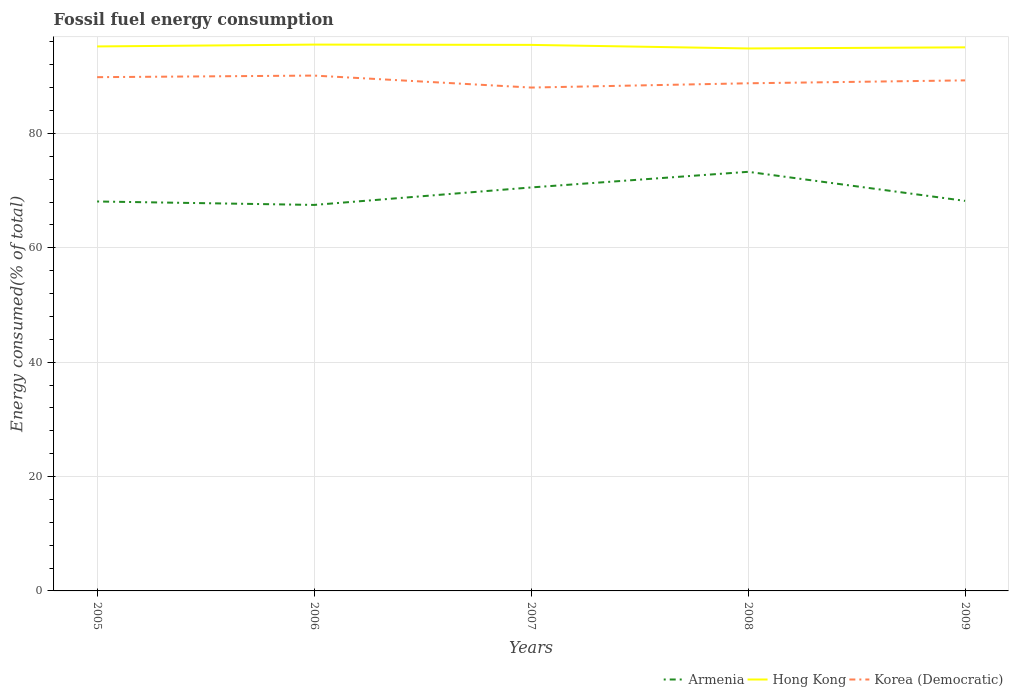Across all years, what is the maximum percentage of energy consumed in Armenia?
Provide a short and direct response. 67.5. In which year was the percentage of energy consumed in Armenia maximum?
Keep it short and to the point. 2006. What is the total percentage of energy consumed in Armenia in the graph?
Your response must be concise. -0.71. What is the difference between the highest and the second highest percentage of energy consumed in Hong Kong?
Your answer should be very brief. 0.67. How many years are there in the graph?
Keep it short and to the point. 5. What is the difference between two consecutive major ticks on the Y-axis?
Offer a very short reply. 20. Does the graph contain grids?
Your response must be concise. Yes. How many legend labels are there?
Ensure brevity in your answer.  3. What is the title of the graph?
Offer a very short reply. Fossil fuel energy consumption. Does "Peru" appear as one of the legend labels in the graph?
Keep it short and to the point. No. What is the label or title of the X-axis?
Your response must be concise. Years. What is the label or title of the Y-axis?
Offer a terse response. Energy consumed(% of total). What is the Energy consumed(% of total) in Armenia in 2005?
Offer a terse response. 68.1. What is the Energy consumed(% of total) in Hong Kong in 2005?
Your answer should be compact. 95.21. What is the Energy consumed(% of total) in Korea (Democratic) in 2005?
Keep it short and to the point. 89.84. What is the Energy consumed(% of total) in Armenia in 2006?
Offer a terse response. 67.5. What is the Energy consumed(% of total) of Hong Kong in 2006?
Your answer should be compact. 95.53. What is the Energy consumed(% of total) in Korea (Democratic) in 2006?
Give a very brief answer. 90.11. What is the Energy consumed(% of total) of Armenia in 2007?
Keep it short and to the point. 70.55. What is the Energy consumed(% of total) in Hong Kong in 2007?
Your answer should be compact. 95.48. What is the Energy consumed(% of total) in Korea (Democratic) in 2007?
Ensure brevity in your answer.  88.02. What is the Energy consumed(% of total) in Armenia in 2008?
Your answer should be compact. 73.29. What is the Energy consumed(% of total) in Hong Kong in 2008?
Ensure brevity in your answer.  94.86. What is the Energy consumed(% of total) in Korea (Democratic) in 2008?
Your answer should be compact. 88.77. What is the Energy consumed(% of total) of Armenia in 2009?
Offer a very short reply. 68.2. What is the Energy consumed(% of total) of Hong Kong in 2009?
Your answer should be very brief. 95.05. What is the Energy consumed(% of total) in Korea (Democratic) in 2009?
Provide a short and direct response. 89.28. Across all years, what is the maximum Energy consumed(% of total) in Armenia?
Provide a short and direct response. 73.29. Across all years, what is the maximum Energy consumed(% of total) in Hong Kong?
Provide a short and direct response. 95.53. Across all years, what is the maximum Energy consumed(% of total) in Korea (Democratic)?
Provide a succinct answer. 90.11. Across all years, what is the minimum Energy consumed(% of total) in Armenia?
Provide a short and direct response. 67.5. Across all years, what is the minimum Energy consumed(% of total) in Hong Kong?
Your answer should be very brief. 94.86. Across all years, what is the minimum Energy consumed(% of total) in Korea (Democratic)?
Your response must be concise. 88.02. What is the total Energy consumed(% of total) in Armenia in the graph?
Provide a short and direct response. 347.64. What is the total Energy consumed(% of total) of Hong Kong in the graph?
Provide a succinct answer. 476.13. What is the total Energy consumed(% of total) in Korea (Democratic) in the graph?
Provide a succinct answer. 446.01. What is the difference between the Energy consumed(% of total) of Armenia in 2005 and that in 2006?
Your answer should be very brief. 0.6. What is the difference between the Energy consumed(% of total) in Hong Kong in 2005 and that in 2006?
Your answer should be very brief. -0.32. What is the difference between the Energy consumed(% of total) in Korea (Democratic) in 2005 and that in 2006?
Ensure brevity in your answer.  -0.28. What is the difference between the Energy consumed(% of total) of Armenia in 2005 and that in 2007?
Make the answer very short. -2.45. What is the difference between the Energy consumed(% of total) of Hong Kong in 2005 and that in 2007?
Offer a very short reply. -0.27. What is the difference between the Energy consumed(% of total) of Korea (Democratic) in 2005 and that in 2007?
Your answer should be very brief. 1.82. What is the difference between the Energy consumed(% of total) of Armenia in 2005 and that in 2008?
Give a very brief answer. -5.19. What is the difference between the Energy consumed(% of total) of Hong Kong in 2005 and that in 2008?
Keep it short and to the point. 0.35. What is the difference between the Energy consumed(% of total) in Korea (Democratic) in 2005 and that in 2008?
Provide a succinct answer. 1.07. What is the difference between the Energy consumed(% of total) of Armenia in 2005 and that in 2009?
Offer a very short reply. -0.11. What is the difference between the Energy consumed(% of total) of Hong Kong in 2005 and that in 2009?
Provide a short and direct response. 0.16. What is the difference between the Energy consumed(% of total) of Korea (Democratic) in 2005 and that in 2009?
Your answer should be compact. 0.56. What is the difference between the Energy consumed(% of total) in Armenia in 2006 and that in 2007?
Provide a succinct answer. -3.06. What is the difference between the Energy consumed(% of total) in Hong Kong in 2006 and that in 2007?
Offer a very short reply. 0.05. What is the difference between the Energy consumed(% of total) of Korea (Democratic) in 2006 and that in 2007?
Offer a very short reply. 2.09. What is the difference between the Energy consumed(% of total) in Armenia in 2006 and that in 2008?
Offer a terse response. -5.79. What is the difference between the Energy consumed(% of total) in Hong Kong in 2006 and that in 2008?
Offer a very short reply. 0.67. What is the difference between the Energy consumed(% of total) of Korea (Democratic) in 2006 and that in 2008?
Keep it short and to the point. 1.35. What is the difference between the Energy consumed(% of total) of Armenia in 2006 and that in 2009?
Give a very brief answer. -0.71. What is the difference between the Energy consumed(% of total) in Hong Kong in 2006 and that in 2009?
Ensure brevity in your answer.  0.48. What is the difference between the Energy consumed(% of total) in Korea (Democratic) in 2006 and that in 2009?
Provide a succinct answer. 0.84. What is the difference between the Energy consumed(% of total) in Armenia in 2007 and that in 2008?
Your answer should be compact. -2.73. What is the difference between the Energy consumed(% of total) of Hong Kong in 2007 and that in 2008?
Offer a very short reply. 0.62. What is the difference between the Energy consumed(% of total) in Korea (Democratic) in 2007 and that in 2008?
Make the answer very short. -0.75. What is the difference between the Energy consumed(% of total) in Armenia in 2007 and that in 2009?
Provide a short and direct response. 2.35. What is the difference between the Energy consumed(% of total) of Hong Kong in 2007 and that in 2009?
Keep it short and to the point. 0.43. What is the difference between the Energy consumed(% of total) in Korea (Democratic) in 2007 and that in 2009?
Make the answer very short. -1.26. What is the difference between the Energy consumed(% of total) in Armenia in 2008 and that in 2009?
Provide a short and direct response. 5.08. What is the difference between the Energy consumed(% of total) in Hong Kong in 2008 and that in 2009?
Make the answer very short. -0.19. What is the difference between the Energy consumed(% of total) in Korea (Democratic) in 2008 and that in 2009?
Make the answer very short. -0.51. What is the difference between the Energy consumed(% of total) of Armenia in 2005 and the Energy consumed(% of total) of Hong Kong in 2006?
Provide a short and direct response. -27.43. What is the difference between the Energy consumed(% of total) in Armenia in 2005 and the Energy consumed(% of total) in Korea (Democratic) in 2006?
Your answer should be compact. -22.01. What is the difference between the Energy consumed(% of total) of Hong Kong in 2005 and the Energy consumed(% of total) of Korea (Democratic) in 2006?
Provide a succinct answer. 5.1. What is the difference between the Energy consumed(% of total) in Armenia in 2005 and the Energy consumed(% of total) in Hong Kong in 2007?
Provide a succinct answer. -27.38. What is the difference between the Energy consumed(% of total) in Armenia in 2005 and the Energy consumed(% of total) in Korea (Democratic) in 2007?
Ensure brevity in your answer.  -19.92. What is the difference between the Energy consumed(% of total) of Hong Kong in 2005 and the Energy consumed(% of total) of Korea (Democratic) in 2007?
Your response must be concise. 7.19. What is the difference between the Energy consumed(% of total) of Armenia in 2005 and the Energy consumed(% of total) of Hong Kong in 2008?
Ensure brevity in your answer.  -26.76. What is the difference between the Energy consumed(% of total) of Armenia in 2005 and the Energy consumed(% of total) of Korea (Democratic) in 2008?
Your answer should be very brief. -20.67. What is the difference between the Energy consumed(% of total) in Hong Kong in 2005 and the Energy consumed(% of total) in Korea (Democratic) in 2008?
Keep it short and to the point. 6.44. What is the difference between the Energy consumed(% of total) of Armenia in 2005 and the Energy consumed(% of total) of Hong Kong in 2009?
Your answer should be compact. -26.95. What is the difference between the Energy consumed(% of total) in Armenia in 2005 and the Energy consumed(% of total) in Korea (Democratic) in 2009?
Provide a succinct answer. -21.18. What is the difference between the Energy consumed(% of total) of Hong Kong in 2005 and the Energy consumed(% of total) of Korea (Democratic) in 2009?
Your response must be concise. 5.93. What is the difference between the Energy consumed(% of total) in Armenia in 2006 and the Energy consumed(% of total) in Hong Kong in 2007?
Your answer should be compact. -27.98. What is the difference between the Energy consumed(% of total) of Armenia in 2006 and the Energy consumed(% of total) of Korea (Democratic) in 2007?
Your response must be concise. -20.52. What is the difference between the Energy consumed(% of total) in Hong Kong in 2006 and the Energy consumed(% of total) in Korea (Democratic) in 2007?
Provide a succinct answer. 7.51. What is the difference between the Energy consumed(% of total) in Armenia in 2006 and the Energy consumed(% of total) in Hong Kong in 2008?
Ensure brevity in your answer.  -27.36. What is the difference between the Energy consumed(% of total) in Armenia in 2006 and the Energy consumed(% of total) in Korea (Democratic) in 2008?
Your answer should be very brief. -21.27. What is the difference between the Energy consumed(% of total) of Hong Kong in 2006 and the Energy consumed(% of total) of Korea (Democratic) in 2008?
Give a very brief answer. 6.77. What is the difference between the Energy consumed(% of total) of Armenia in 2006 and the Energy consumed(% of total) of Hong Kong in 2009?
Your answer should be compact. -27.55. What is the difference between the Energy consumed(% of total) of Armenia in 2006 and the Energy consumed(% of total) of Korea (Democratic) in 2009?
Make the answer very short. -21.78. What is the difference between the Energy consumed(% of total) in Hong Kong in 2006 and the Energy consumed(% of total) in Korea (Democratic) in 2009?
Keep it short and to the point. 6.26. What is the difference between the Energy consumed(% of total) of Armenia in 2007 and the Energy consumed(% of total) of Hong Kong in 2008?
Your answer should be very brief. -24.3. What is the difference between the Energy consumed(% of total) of Armenia in 2007 and the Energy consumed(% of total) of Korea (Democratic) in 2008?
Provide a succinct answer. -18.21. What is the difference between the Energy consumed(% of total) of Hong Kong in 2007 and the Energy consumed(% of total) of Korea (Democratic) in 2008?
Your answer should be very brief. 6.71. What is the difference between the Energy consumed(% of total) in Armenia in 2007 and the Energy consumed(% of total) in Hong Kong in 2009?
Keep it short and to the point. -24.5. What is the difference between the Energy consumed(% of total) of Armenia in 2007 and the Energy consumed(% of total) of Korea (Democratic) in 2009?
Keep it short and to the point. -18.72. What is the difference between the Energy consumed(% of total) in Hong Kong in 2007 and the Energy consumed(% of total) in Korea (Democratic) in 2009?
Give a very brief answer. 6.2. What is the difference between the Energy consumed(% of total) of Armenia in 2008 and the Energy consumed(% of total) of Hong Kong in 2009?
Make the answer very short. -21.76. What is the difference between the Energy consumed(% of total) of Armenia in 2008 and the Energy consumed(% of total) of Korea (Democratic) in 2009?
Your answer should be compact. -15.99. What is the difference between the Energy consumed(% of total) in Hong Kong in 2008 and the Energy consumed(% of total) in Korea (Democratic) in 2009?
Offer a terse response. 5.58. What is the average Energy consumed(% of total) of Armenia per year?
Make the answer very short. 69.53. What is the average Energy consumed(% of total) of Hong Kong per year?
Your answer should be compact. 95.23. What is the average Energy consumed(% of total) in Korea (Democratic) per year?
Provide a succinct answer. 89.2. In the year 2005, what is the difference between the Energy consumed(% of total) of Armenia and Energy consumed(% of total) of Hong Kong?
Your response must be concise. -27.11. In the year 2005, what is the difference between the Energy consumed(% of total) of Armenia and Energy consumed(% of total) of Korea (Democratic)?
Provide a short and direct response. -21.74. In the year 2005, what is the difference between the Energy consumed(% of total) in Hong Kong and Energy consumed(% of total) in Korea (Democratic)?
Provide a succinct answer. 5.37. In the year 2006, what is the difference between the Energy consumed(% of total) in Armenia and Energy consumed(% of total) in Hong Kong?
Provide a short and direct response. -28.04. In the year 2006, what is the difference between the Energy consumed(% of total) of Armenia and Energy consumed(% of total) of Korea (Democratic)?
Offer a terse response. -22.62. In the year 2006, what is the difference between the Energy consumed(% of total) of Hong Kong and Energy consumed(% of total) of Korea (Democratic)?
Keep it short and to the point. 5.42. In the year 2007, what is the difference between the Energy consumed(% of total) of Armenia and Energy consumed(% of total) of Hong Kong?
Provide a short and direct response. -24.93. In the year 2007, what is the difference between the Energy consumed(% of total) of Armenia and Energy consumed(% of total) of Korea (Democratic)?
Your answer should be very brief. -17.47. In the year 2007, what is the difference between the Energy consumed(% of total) of Hong Kong and Energy consumed(% of total) of Korea (Democratic)?
Provide a succinct answer. 7.46. In the year 2008, what is the difference between the Energy consumed(% of total) in Armenia and Energy consumed(% of total) in Hong Kong?
Keep it short and to the point. -21.57. In the year 2008, what is the difference between the Energy consumed(% of total) in Armenia and Energy consumed(% of total) in Korea (Democratic)?
Your answer should be compact. -15.48. In the year 2008, what is the difference between the Energy consumed(% of total) in Hong Kong and Energy consumed(% of total) in Korea (Democratic)?
Your answer should be compact. 6.09. In the year 2009, what is the difference between the Energy consumed(% of total) in Armenia and Energy consumed(% of total) in Hong Kong?
Your answer should be very brief. -26.85. In the year 2009, what is the difference between the Energy consumed(% of total) in Armenia and Energy consumed(% of total) in Korea (Democratic)?
Your answer should be compact. -21.07. In the year 2009, what is the difference between the Energy consumed(% of total) in Hong Kong and Energy consumed(% of total) in Korea (Democratic)?
Offer a very short reply. 5.77. What is the ratio of the Energy consumed(% of total) in Armenia in 2005 to that in 2006?
Your answer should be very brief. 1.01. What is the ratio of the Energy consumed(% of total) of Armenia in 2005 to that in 2007?
Give a very brief answer. 0.97. What is the ratio of the Energy consumed(% of total) in Hong Kong in 2005 to that in 2007?
Ensure brevity in your answer.  1. What is the ratio of the Energy consumed(% of total) in Korea (Democratic) in 2005 to that in 2007?
Your answer should be very brief. 1.02. What is the ratio of the Energy consumed(% of total) in Armenia in 2005 to that in 2008?
Ensure brevity in your answer.  0.93. What is the ratio of the Energy consumed(% of total) in Hong Kong in 2005 to that in 2008?
Provide a succinct answer. 1. What is the ratio of the Energy consumed(% of total) of Korea (Democratic) in 2005 to that in 2008?
Offer a very short reply. 1.01. What is the ratio of the Energy consumed(% of total) in Korea (Democratic) in 2005 to that in 2009?
Offer a terse response. 1.01. What is the ratio of the Energy consumed(% of total) in Armenia in 2006 to that in 2007?
Give a very brief answer. 0.96. What is the ratio of the Energy consumed(% of total) in Hong Kong in 2006 to that in 2007?
Your response must be concise. 1. What is the ratio of the Energy consumed(% of total) of Korea (Democratic) in 2006 to that in 2007?
Provide a short and direct response. 1.02. What is the ratio of the Energy consumed(% of total) of Armenia in 2006 to that in 2008?
Make the answer very short. 0.92. What is the ratio of the Energy consumed(% of total) of Hong Kong in 2006 to that in 2008?
Your response must be concise. 1.01. What is the ratio of the Energy consumed(% of total) of Korea (Democratic) in 2006 to that in 2008?
Your response must be concise. 1.02. What is the ratio of the Energy consumed(% of total) of Korea (Democratic) in 2006 to that in 2009?
Give a very brief answer. 1.01. What is the ratio of the Energy consumed(% of total) in Armenia in 2007 to that in 2008?
Offer a terse response. 0.96. What is the ratio of the Energy consumed(% of total) in Hong Kong in 2007 to that in 2008?
Keep it short and to the point. 1.01. What is the ratio of the Energy consumed(% of total) of Armenia in 2007 to that in 2009?
Provide a short and direct response. 1.03. What is the ratio of the Energy consumed(% of total) in Korea (Democratic) in 2007 to that in 2009?
Provide a short and direct response. 0.99. What is the ratio of the Energy consumed(% of total) in Armenia in 2008 to that in 2009?
Keep it short and to the point. 1.07. What is the difference between the highest and the second highest Energy consumed(% of total) of Armenia?
Keep it short and to the point. 2.73. What is the difference between the highest and the second highest Energy consumed(% of total) in Hong Kong?
Your answer should be compact. 0.05. What is the difference between the highest and the second highest Energy consumed(% of total) in Korea (Democratic)?
Provide a short and direct response. 0.28. What is the difference between the highest and the lowest Energy consumed(% of total) in Armenia?
Your answer should be very brief. 5.79. What is the difference between the highest and the lowest Energy consumed(% of total) in Hong Kong?
Keep it short and to the point. 0.67. What is the difference between the highest and the lowest Energy consumed(% of total) of Korea (Democratic)?
Your response must be concise. 2.09. 